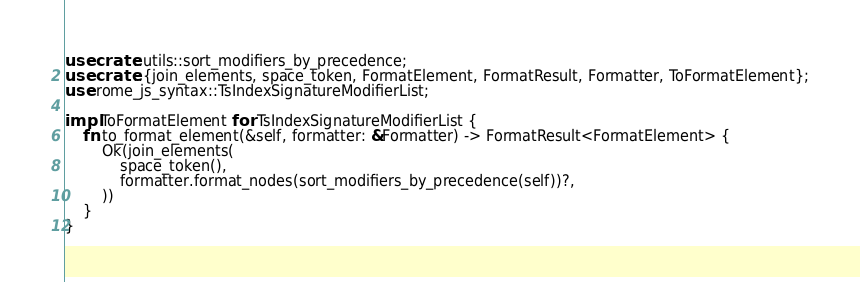Convert code to text. <code><loc_0><loc_0><loc_500><loc_500><_Rust_>use crate::utils::sort_modifiers_by_precedence;
use crate::{join_elements, space_token, FormatElement, FormatResult, Formatter, ToFormatElement};
use rome_js_syntax::TsIndexSignatureModifierList;

impl ToFormatElement for TsIndexSignatureModifierList {
    fn to_format_element(&self, formatter: &Formatter) -> FormatResult<FormatElement> {
        Ok(join_elements(
            space_token(),
            formatter.format_nodes(sort_modifiers_by_precedence(self))?,
        ))
    }
}
</code> 